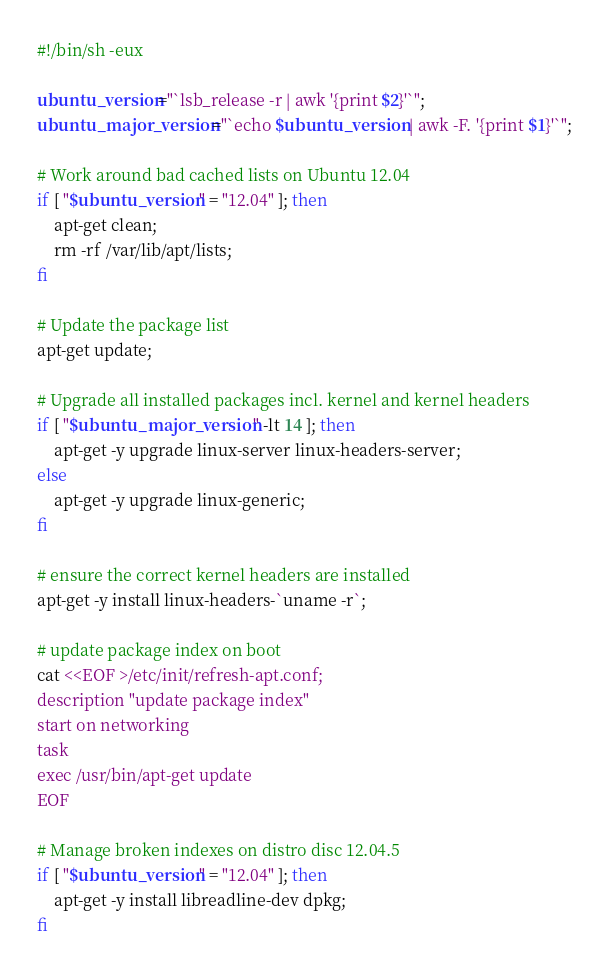<code> <loc_0><loc_0><loc_500><loc_500><_Bash_>#!/bin/sh -eux

ubuntu_version="`lsb_release -r | awk '{print $2}'`";
ubuntu_major_version="`echo $ubuntu_version | awk -F. '{print $1}'`";

# Work around bad cached lists on Ubuntu 12.04
if [ "$ubuntu_version" = "12.04" ]; then
    apt-get clean;
    rm -rf /var/lib/apt/lists;
fi

# Update the package list
apt-get update;

# Upgrade all installed packages incl. kernel and kernel headers
if [ "$ubuntu_major_version" -lt 14 ]; then
    apt-get -y upgrade linux-server linux-headers-server;
else
    apt-get -y upgrade linux-generic;
fi

# ensure the correct kernel headers are installed
apt-get -y install linux-headers-`uname -r`;

# update package index on boot
cat <<EOF >/etc/init/refresh-apt.conf;
description "update package index"
start on networking
task
exec /usr/bin/apt-get update
EOF

# Manage broken indexes on distro disc 12.04.5
if [ "$ubuntu_version" = "12.04" ]; then
    apt-get -y install libreadline-dev dpkg;
fi
</code> 